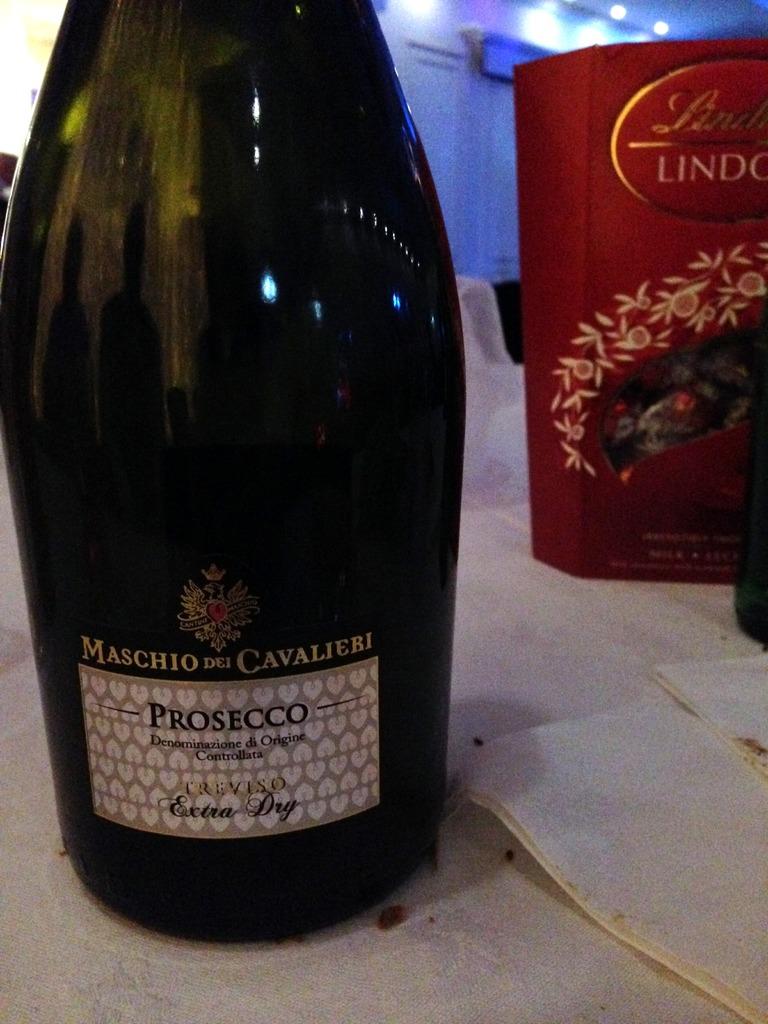What kind of wine is it?
Make the answer very short. Prosecco. 